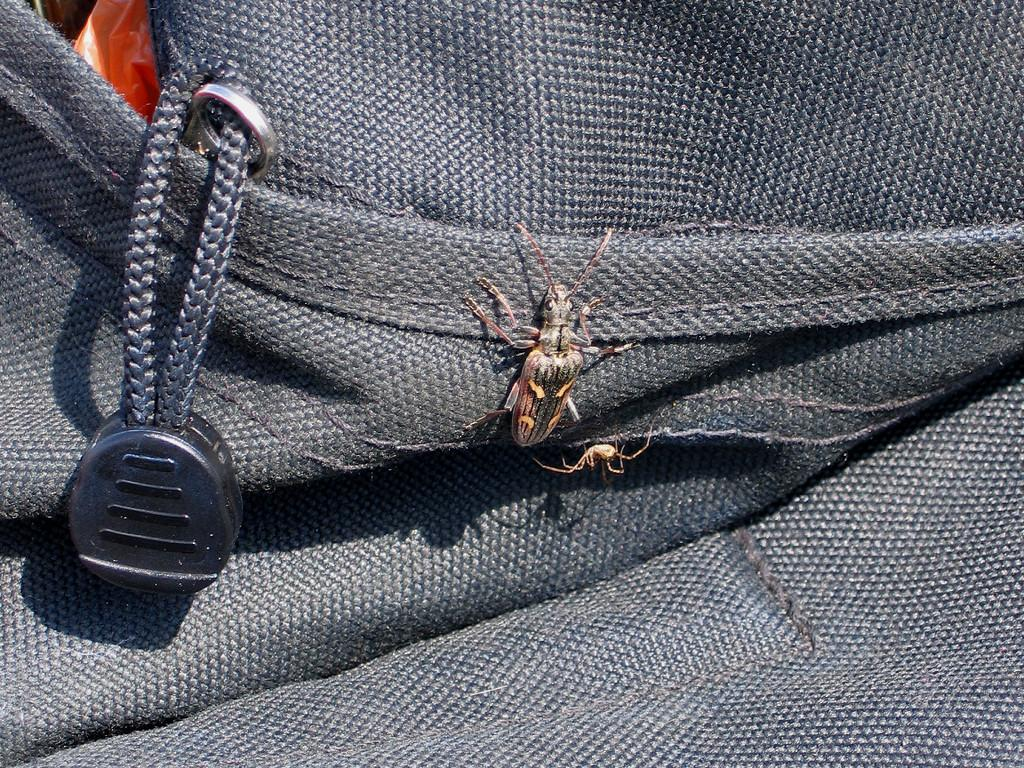What is present on the bag in the image? There is an insect on the bag. What can be found inside the bag? There is a red color cover inside the bag. Can you see the insect sparking inside the bag? There is no mention of a spark in the image, and the insect is on the bag, not inside it. How does the window affect the appearance of the insect on the bag? There is no window present in the image, so it cannot affect the appearance of the insect on the bag. 